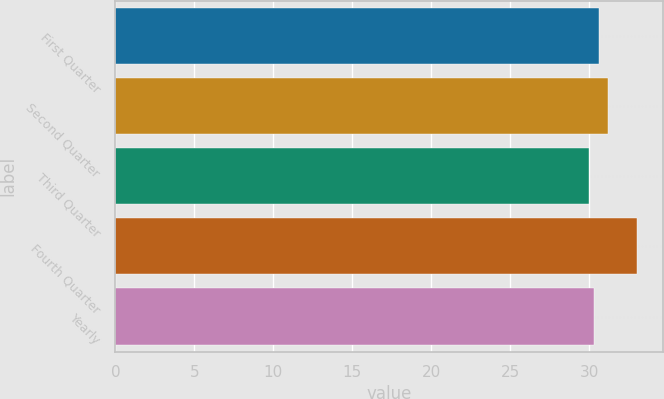Convert chart. <chart><loc_0><loc_0><loc_500><loc_500><bar_chart><fcel>First Quarter<fcel>Second Quarter<fcel>Third Quarter<fcel>Fourth Quarter<fcel>Yearly<nl><fcel>30.6<fcel>31.17<fcel>29.98<fcel>33.04<fcel>30.29<nl></chart> 